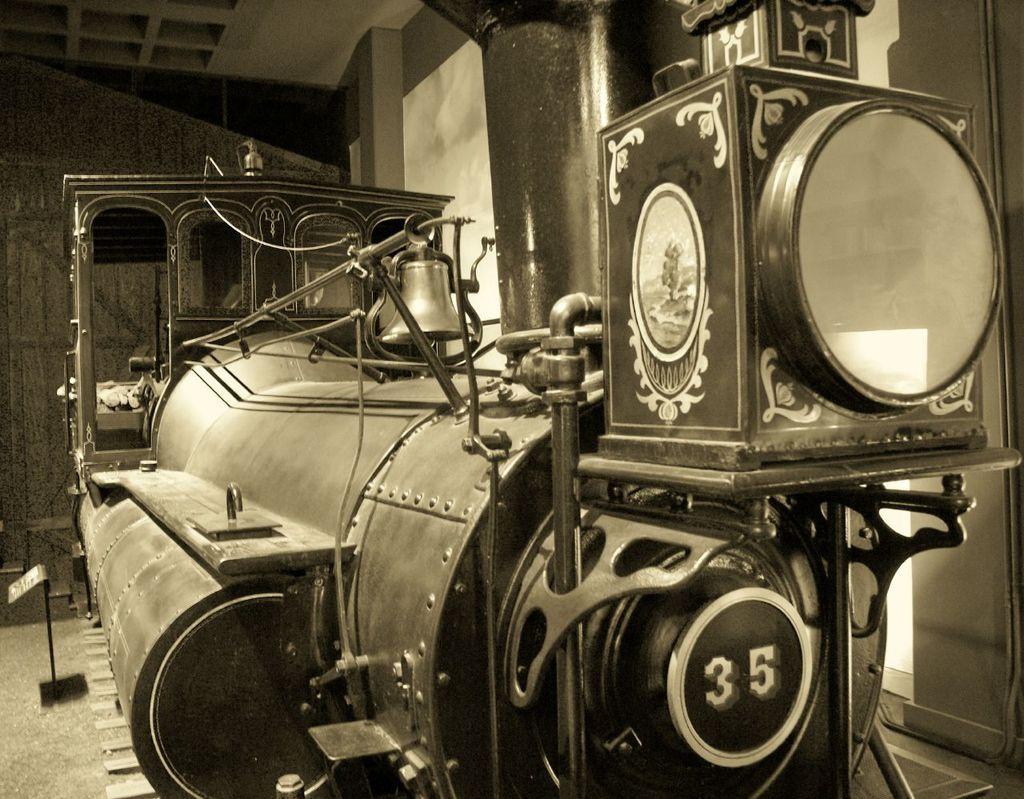Could you give a brief overview of what you see in this image? In this picture we can see a train engine, there is a bell here, in the background we can see a wall, it is a black and white picture. 